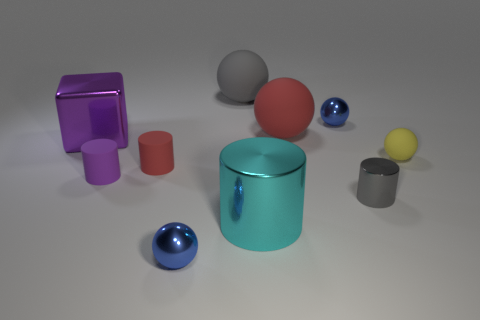Is the number of tiny yellow matte objects that are left of the tiny purple matte cylinder the same as the number of tiny gray cylinders?
Your answer should be very brief. No. What size is the red matte ball?
Offer a terse response. Large. What number of purple metallic objects are right of the tiny purple cylinder left of the tiny red rubber object?
Ensure brevity in your answer.  0. There is a thing that is in front of the small purple matte cylinder and behind the large shiny cylinder; what shape is it?
Your answer should be compact. Cylinder. How many big metallic things are the same color as the block?
Provide a succinct answer. 0. Is there a blue ball that is in front of the big metallic thing to the left of the small sphere that is in front of the large cylinder?
Make the answer very short. Yes. What is the size of the shiny object that is both in front of the small gray cylinder and to the left of the gray matte object?
Your answer should be compact. Small. How many other balls have the same material as the gray sphere?
Offer a terse response. 2. How many balls are either blue shiny things or matte objects?
Offer a terse response. 5. What is the size of the gray object to the right of the gray thing behind the big red rubber ball on the right side of the large metallic block?
Your answer should be compact. Small. 